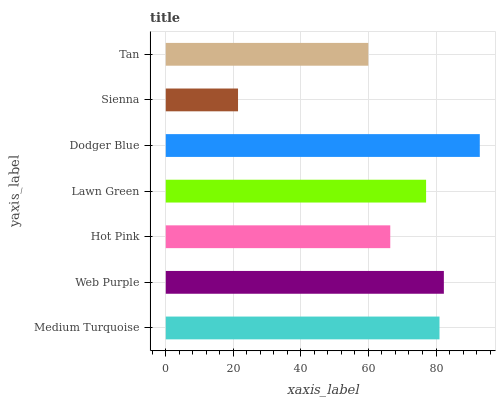Is Sienna the minimum?
Answer yes or no. Yes. Is Dodger Blue the maximum?
Answer yes or no. Yes. Is Web Purple the minimum?
Answer yes or no. No. Is Web Purple the maximum?
Answer yes or no. No. Is Web Purple greater than Medium Turquoise?
Answer yes or no. Yes. Is Medium Turquoise less than Web Purple?
Answer yes or no. Yes. Is Medium Turquoise greater than Web Purple?
Answer yes or no. No. Is Web Purple less than Medium Turquoise?
Answer yes or no. No. Is Lawn Green the high median?
Answer yes or no. Yes. Is Lawn Green the low median?
Answer yes or no. Yes. Is Dodger Blue the high median?
Answer yes or no. No. Is Tan the low median?
Answer yes or no. No. 